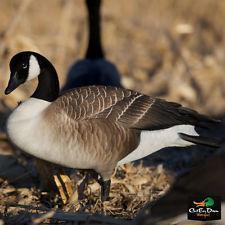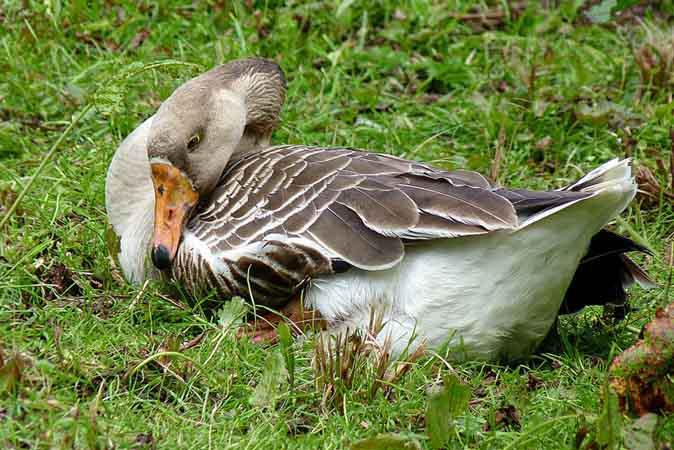The first image is the image on the left, the second image is the image on the right. Assess this claim about the two images: "The bird in the image on the right is sitting in the grass.". Correct or not? Answer yes or no. Yes. The first image is the image on the left, the second image is the image on the right. Evaluate the accuracy of this statement regarding the images: "There is a single geese in the foreground in each image.". Is it true? Answer yes or no. Yes. 